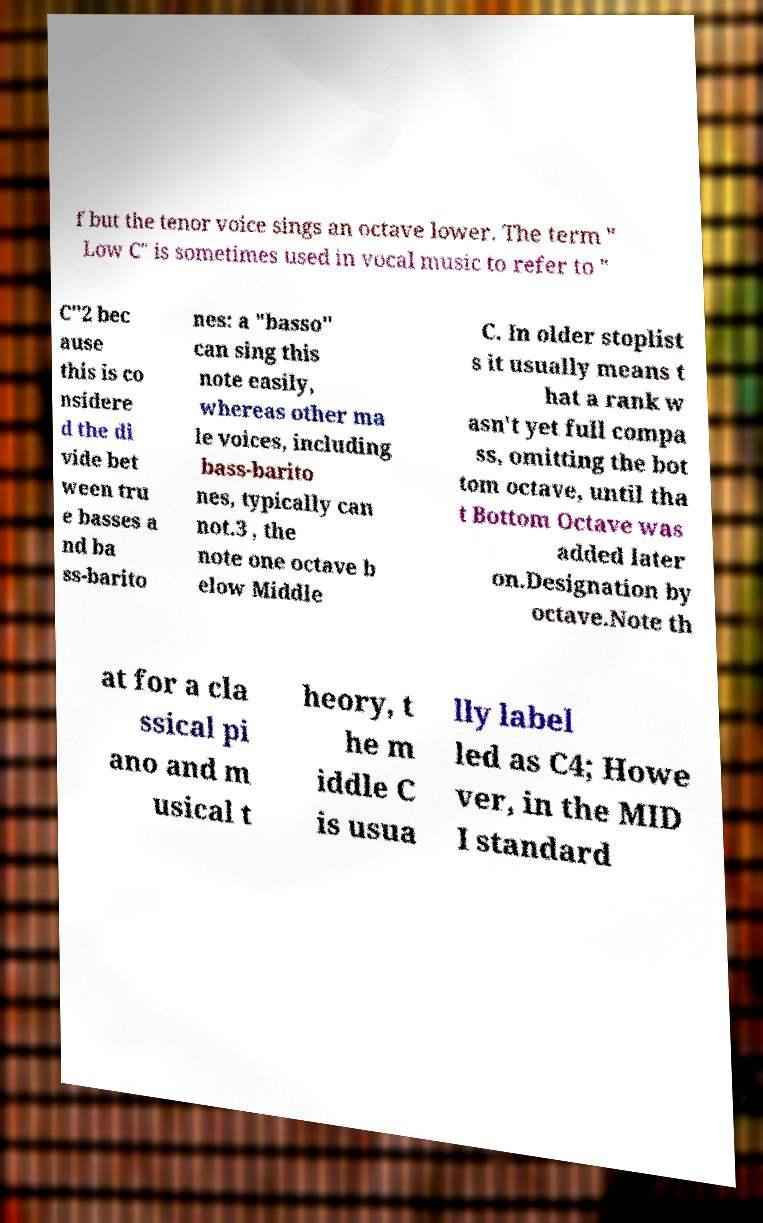Can you read and provide the text displayed in the image?This photo seems to have some interesting text. Can you extract and type it out for me? f but the tenor voice sings an octave lower. The term " Low C" is sometimes used in vocal music to refer to " C"2 bec ause this is co nsidere d the di vide bet ween tru e basses a nd ba ss-barito nes: a "basso" can sing this note easily, whereas other ma le voices, including bass-barito nes, typically can not.3 , the note one octave b elow Middle C. In older stoplist s it usually means t hat a rank w asn't yet full compa ss, omitting the bot tom octave, until tha t Bottom Octave was added later on.Designation by octave.Note th at for a cla ssical pi ano and m usical t heory, t he m iddle C is usua lly label led as C4; Howe ver, in the MID I standard 